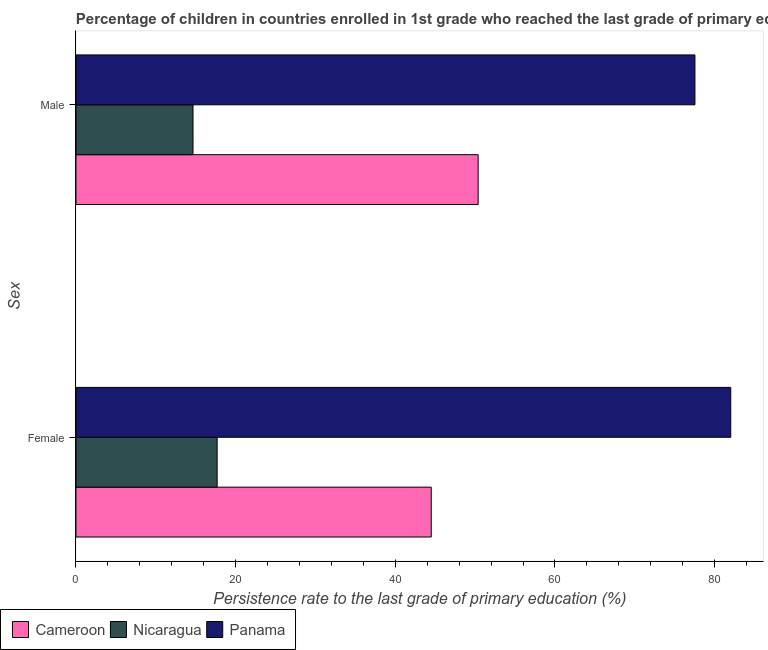How many different coloured bars are there?
Offer a very short reply. 3. How many groups of bars are there?
Give a very brief answer. 2. Are the number of bars per tick equal to the number of legend labels?
Your answer should be very brief. Yes. How many bars are there on the 2nd tick from the bottom?
Make the answer very short. 3. What is the persistence rate of female students in Cameroon?
Provide a succinct answer. 44.5. Across all countries, what is the maximum persistence rate of female students?
Give a very brief answer. 82.02. Across all countries, what is the minimum persistence rate of male students?
Your answer should be compact. 14.66. In which country was the persistence rate of female students maximum?
Give a very brief answer. Panama. In which country was the persistence rate of male students minimum?
Your response must be concise. Nicaragua. What is the total persistence rate of female students in the graph?
Provide a succinct answer. 144.2. What is the difference between the persistence rate of female students in Panama and that in Nicaragua?
Your answer should be compact. 64.34. What is the difference between the persistence rate of female students in Nicaragua and the persistence rate of male students in Cameroon?
Offer a very short reply. -32.69. What is the average persistence rate of female students per country?
Offer a terse response. 48.07. What is the difference between the persistence rate of female students and persistence rate of male students in Panama?
Keep it short and to the point. 4.49. What is the ratio of the persistence rate of female students in Cameroon to that in Nicaragua?
Offer a terse response. 2.52. What does the 3rd bar from the top in Female represents?
Provide a short and direct response. Cameroon. What does the 3rd bar from the bottom in Female represents?
Your answer should be very brief. Panama. Are all the bars in the graph horizontal?
Give a very brief answer. Yes. What is the difference between two consecutive major ticks on the X-axis?
Provide a succinct answer. 20. Does the graph contain grids?
Provide a succinct answer. No. Where does the legend appear in the graph?
Your answer should be very brief. Bottom left. What is the title of the graph?
Offer a terse response. Percentage of children in countries enrolled in 1st grade who reached the last grade of primary education. Does "Lao PDR" appear as one of the legend labels in the graph?
Provide a succinct answer. No. What is the label or title of the X-axis?
Ensure brevity in your answer.  Persistence rate to the last grade of primary education (%). What is the label or title of the Y-axis?
Offer a very short reply. Sex. What is the Persistence rate to the last grade of primary education (%) of Cameroon in Female?
Give a very brief answer. 44.5. What is the Persistence rate to the last grade of primary education (%) in Nicaragua in Female?
Provide a short and direct response. 17.68. What is the Persistence rate to the last grade of primary education (%) of Panama in Female?
Your answer should be compact. 82.02. What is the Persistence rate to the last grade of primary education (%) in Cameroon in Male?
Ensure brevity in your answer.  50.38. What is the Persistence rate to the last grade of primary education (%) in Nicaragua in Male?
Provide a short and direct response. 14.66. What is the Persistence rate to the last grade of primary education (%) in Panama in Male?
Offer a terse response. 77.53. Across all Sex, what is the maximum Persistence rate to the last grade of primary education (%) of Cameroon?
Give a very brief answer. 50.38. Across all Sex, what is the maximum Persistence rate to the last grade of primary education (%) of Nicaragua?
Make the answer very short. 17.68. Across all Sex, what is the maximum Persistence rate to the last grade of primary education (%) in Panama?
Keep it short and to the point. 82.02. Across all Sex, what is the minimum Persistence rate to the last grade of primary education (%) of Cameroon?
Give a very brief answer. 44.5. Across all Sex, what is the minimum Persistence rate to the last grade of primary education (%) in Nicaragua?
Offer a terse response. 14.66. Across all Sex, what is the minimum Persistence rate to the last grade of primary education (%) in Panama?
Your answer should be compact. 77.53. What is the total Persistence rate to the last grade of primary education (%) in Cameroon in the graph?
Provide a succinct answer. 94.88. What is the total Persistence rate to the last grade of primary education (%) in Nicaragua in the graph?
Make the answer very short. 32.34. What is the total Persistence rate to the last grade of primary education (%) in Panama in the graph?
Provide a short and direct response. 159.55. What is the difference between the Persistence rate to the last grade of primary education (%) of Cameroon in Female and that in Male?
Offer a terse response. -5.88. What is the difference between the Persistence rate to the last grade of primary education (%) of Nicaragua in Female and that in Male?
Offer a very short reply. 3.02. What is the difference between the Persistence rate to the last grade of primary education (%) in Panama in Female and that in Male?
Ensure brevity in your answer.  4.49. What is the difference between the Persistence rate to the last grade of primary education (%) in Cameroon in Female and the Persistence rate to the last grade of primary education (%) in Nicaragua in Male?
Provide a succinct answer. 29.84. What is the difference between the Persistence rate to the last grade of primary education (%) of Cameroon in Female and the Persistence rate to the last grade of primary education (%) of Panama in Male?
Keep it short and to the point. -33.03. What is the difference between the Persistence rate to the last grade of primary education (%) of Nicaragua in Female and the Persistence rate to the last grade of primary education (%) of Panama in Male?
Your answer should be very brief. -59.85. What is the average Persistence rate to the last grade of primary education (%) of Cameroon per Sex?
Offer a terse response. 47.44. What is the average Persistence rate to the last grade of primary education (%) in Nicaragua per Sex?
Provide a short and direct response. 16.17. What is the average Persistence rate to the last grade of primary education (%) of Panama per Sex?
Offer a very short reply. 79.78. What is the difference between the Persistence rate to the last grade of primary education (%) of Cameroon and Persistence rate to the last grade of primary education (%) of Nicaragua in Female?
Give a very brief answer. 26.82. What is the difference between the Persistence rate to the last grade of primary education (%) in Cameroon and Persistence rate to the last grade of primary education (%) in Panama in Female?
Ensure brevity in your answer.  -37.52. What is the difference between the Persistence rate to the last grade of primary education (%) in Nicaragua and Persistence rate to the last grade of primary education (%) in Panama in Female?
Offer a very short reply. -64.34. What is the difference between the Persistence rate to the last grade of primary education (%) in Cameroon and Persistence rate to the last grade of primary education (%) in Nicaragua in Male?
Ensure brevity in your answer.  35.72. What is the difference between the Persistence rate to the last grade of primary education (%) in Cameroon and Persistence rate to the last grade of primary education (%) in Panama in Male?
Provide a succinct answer. -27.16. What is the difference between the Persistence rate to the last grade of primary education (%) in Nicaragua and Persistence rate to the last grade of primary education (%) in Panama in Male?
Offer a very short reply. -62.87. What is the ratio of the Persistence rate to the last grade of primary education (%) in Cameroon in Female to that in Male?
Your response must be concise. 0.88. What is the ratio of the Persistence rate to the last grade of primary education (%) in Nicaragua in Female to that in Male?
Offer a very short reply. 1.21. What is the ratio of the Persistence rate to the last grade of primary education (%) in Panama in Female to that in Male?
Give a very brief answer. 1.06. What is the difference between the highest and the second highest Persistence rate to the last grade of primary education (%) of Cameroon?
Your answer should be compact. 5.88. What is the difference between the highest and the second highest Persistence rate to the last grade of primary education (%) in Nicaragua?
Provide a short and direct response. 3.02. What is the difference between the highest and the second highest Persistence rate to the last grade of primary education (%) of Panama?
Provide a short and direct response. 4.49. What is the difference between the highest and the lowest Persistence rate to the last grade of primary education (%) of Cameroon?
Ensure brevity in your answer.  5.88. What is the difference between the highest and the lowest Persistence rate to the last grade of primary education (%) of Nicaragua?
Your answer should be very brief. 3.02. What is the difference between the highest and the lowest Persistence rate to the last grade of primary education (%) in Panama?
Your response must be concise. 4.49. 